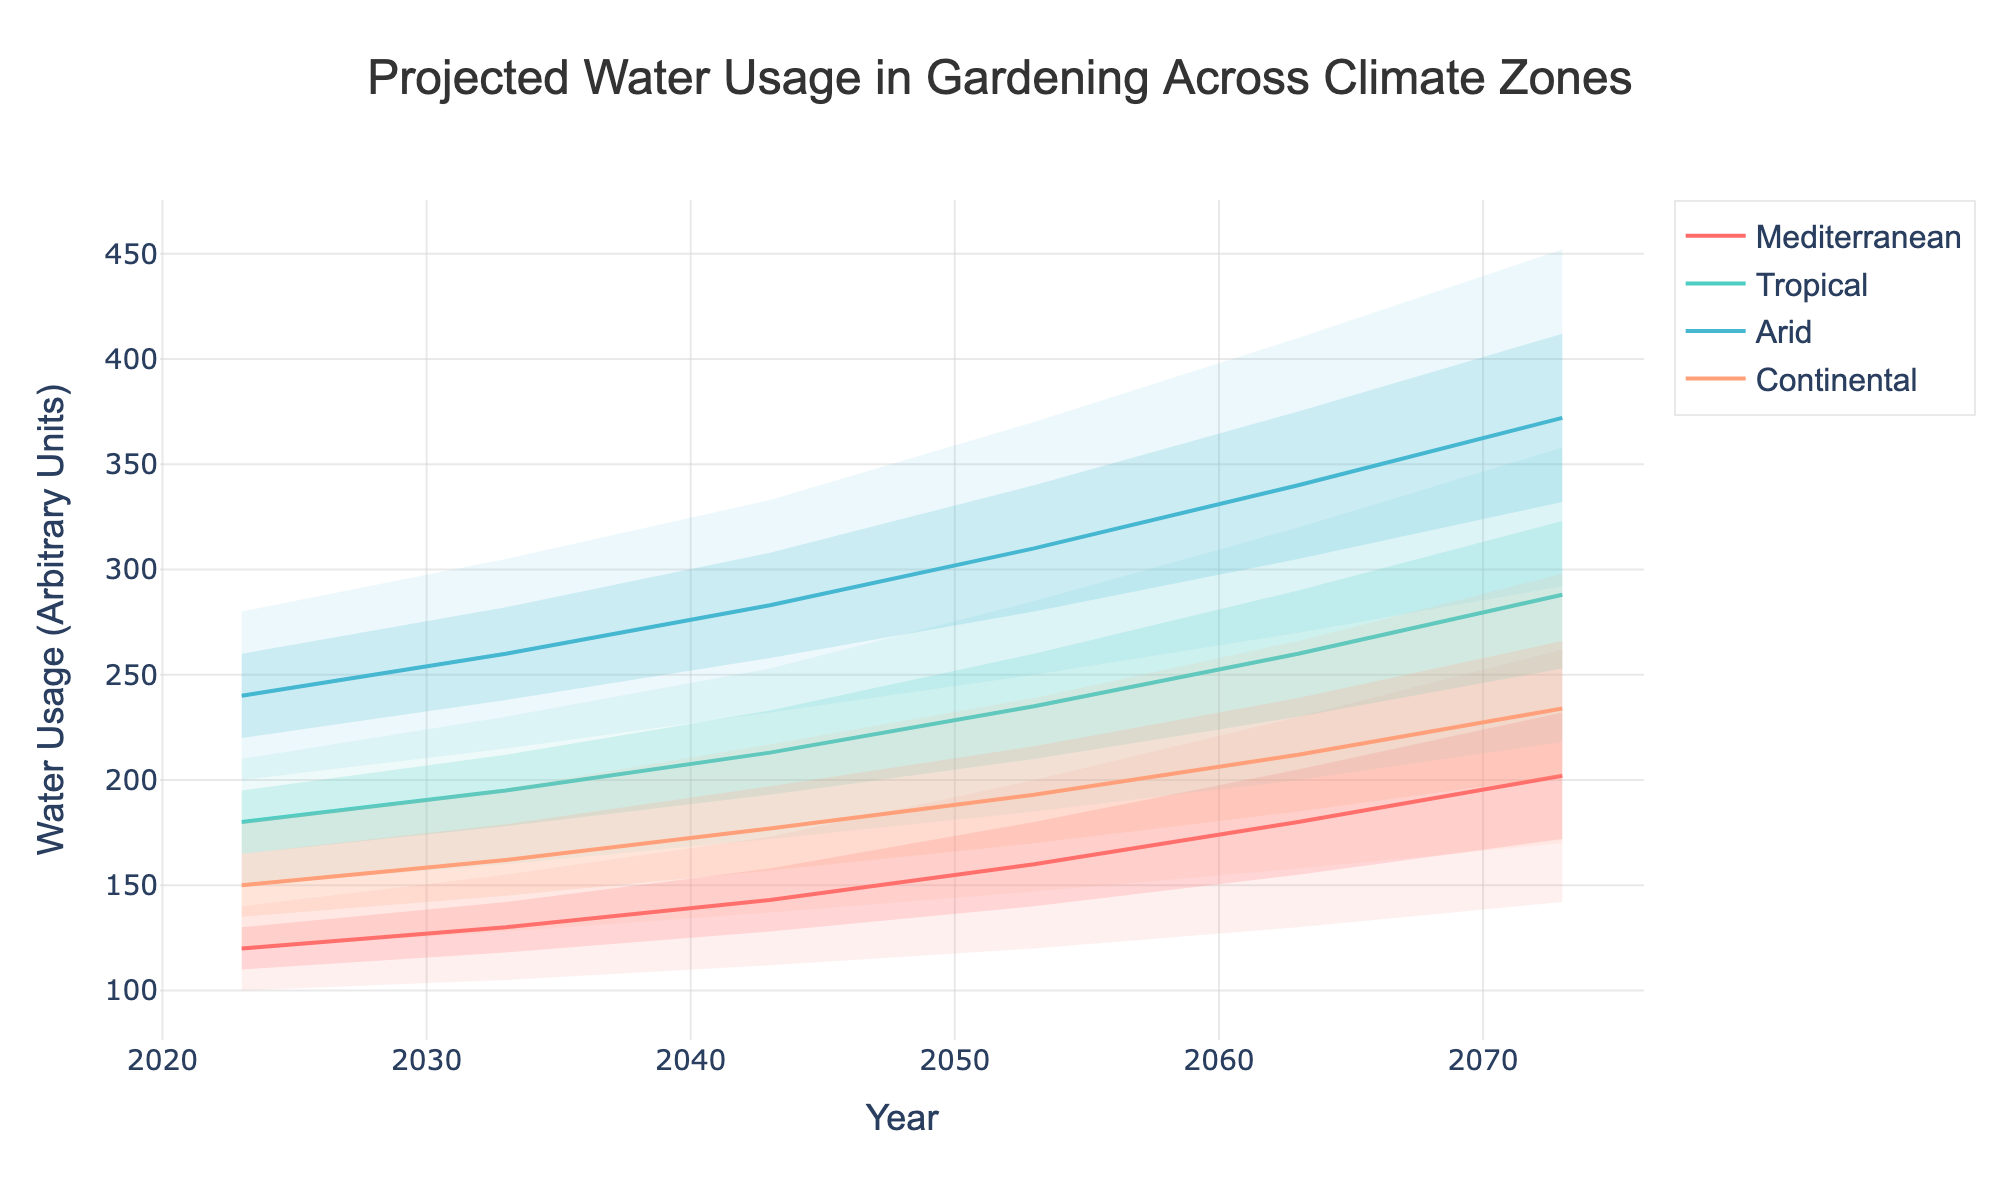What is the title of the chart? The title of the chart is displayed at the top and reads "Projected Water Usage in Gardening Across Climate Zones."
Answer: Projected Water Usage in Gardening Across Climate Zones What are the climate zones presented in the chart? The climate zones can be identified by the different colored lines: Mediterranean, Tropical, Arid, and Continental.
Answer: Mediterranean, Tropical, Arid, Continental In 2023, which zone had the highest median water usage? The median level of water usage in 2023 for each zone is the middle line of the shaded area for that year. The values are: Mediterranean (120), Tropical (180), Arid (240), Continental (150). The highest is for the Arid zone.
Answer: Arid How does the projected median water usage in the Mediterranean zone in 2073 compare to that in 2023? For the Mediterranean zone, we compare the median values in 2073 (202) and in 2023 (120). 202 - 120 = 82, showing an increase of 82 units.
Answer: Increased by 82 units What is the difference in the highest projected water usage between the Tropical and Continental zones in 2063? For 2063, the highest projected water usage in the Tropical zone is 320 and in the Continental zone is 266. 320 - 266 = 54.
Answer: 54 units Which zone demonstrates the largest spread in water usage projections in 2073? The spread can be determined by looking at the difference between the highest and lowest shaded boundaries for each zone in 2073. Mediterranean (262-142=120), Tropical (358-218=140), Arid (452-292=160), Continental (298-170=128). The Arid zone has the largest spread.
Answer: Arid How do the projected mid-range values (LowMid and HighMid) for the Arid zone in 2053 compare to the values in 2023? For the Arid zone, LowMid in 2053 is 280 and in 2023 is 220; the difference is 280 - 220 = 60. HighMid in 2053 is 340 and in 2023 is 260; the difference is 340 - 260 = 80.
Answer: LowMid increased by 60, HighMid increased by 80 In what year is the median projected water usage in the Continental zone expected to reach 177 units? By checking the median values for the Continental zone across the years, the median is 177 in the year 2043.
Answer: 2043 By how much does the highest projected value for the Mediterranean zone increase from 2043 to 2073? For the Mediterranean zone, the highest projected value in 2043 is 173, and in 2073 it is 262. 262 - 173 = 89.
Answer: 89 units What is the trend in median water usage for the Tropical zone over the projected years? Observing the median values for the Tropical zone across the years: 2023 (180), 2033 (195), 2043 (213), 2053 (235), 2063 (260), 2073 (288). The trend shows a steady increase.
Answer: Steady Increase 